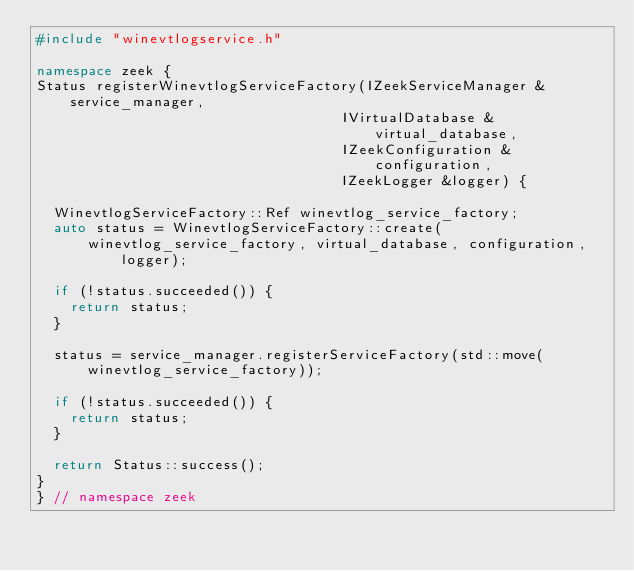<code> <loc_0><loc_0><loc_500><loc_500><_C++_>#include "winevtlogservice.h"

namespace zeek {
Status registerWinevtlogServiceFactory(IZeekServiceManager &service_manager,
                                    IVirtualDatabase &virtual_database,
                                    IZeekConfiguration &configuration,
                                    IZeekLogger &logger) {

  WinevtlogServiceFactory::Ref winevtlog_service_factory;
  auto status = WinevtlogServiceFactory::create(
      winevtlog_service_factory, virtual_database, configuration, logger);

  if (!status.succeeded()) {
    return status;
  }

  status = service_manager.registerServiceFactory(std::move(winevtlog_service_factory));

  if (!status.succeeded()) {
    return status;
  }

  return Status::success();
}
} // namespace zeek
</code> 